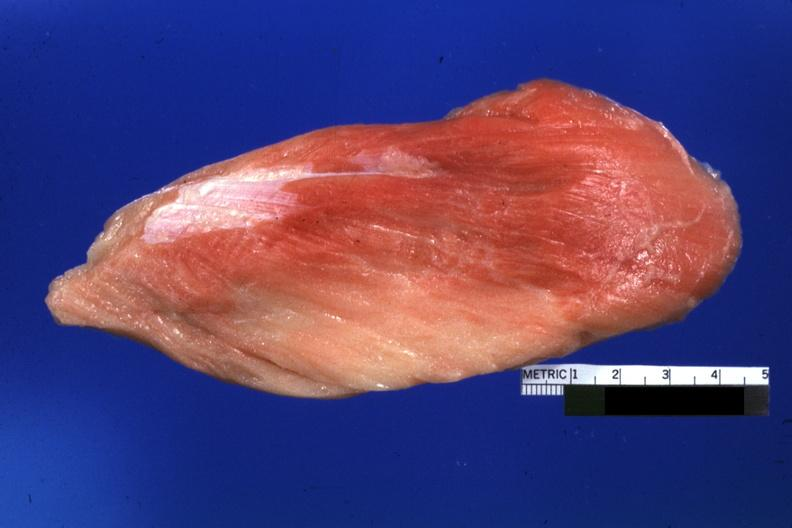s soft tissue present?
Answer the question using a single word or phrase. Yes 